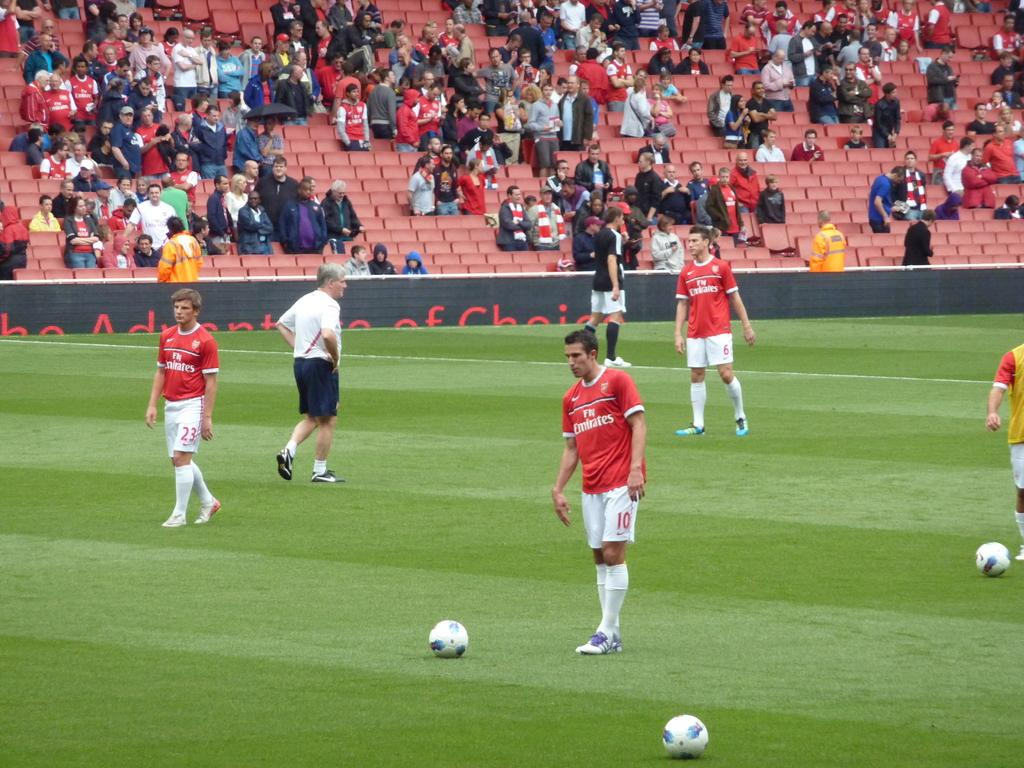<image>
Give a short and clear explanation of the subsequent image. A group of soccer players wearing red and white uniforms with Fly Emirates written on the front of the jersey. 